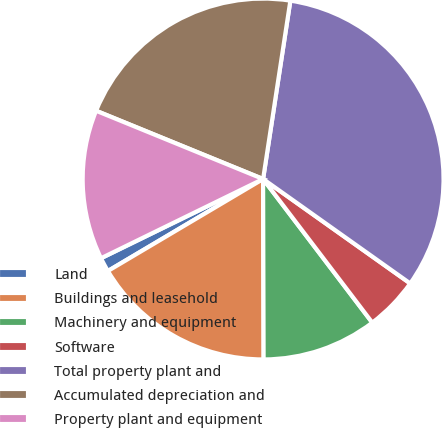<chart> <loc_0><loc_0><loc_500><loc_500><pie_chart><fcel>Land<fcel>Buildings and leasehold<fcel>Machinery and equipment<fcel>Software<fcel>Total property plant and<fcel>Accumulated depreciation and<fcel>Property plant and equipment<nl><fcel>1.28%<fcel>16.53%<fcel>10.3%<fcel>4.83%<fcel>32.41%<fcel>21.24%<fcel>13.41%<nl></chart> 